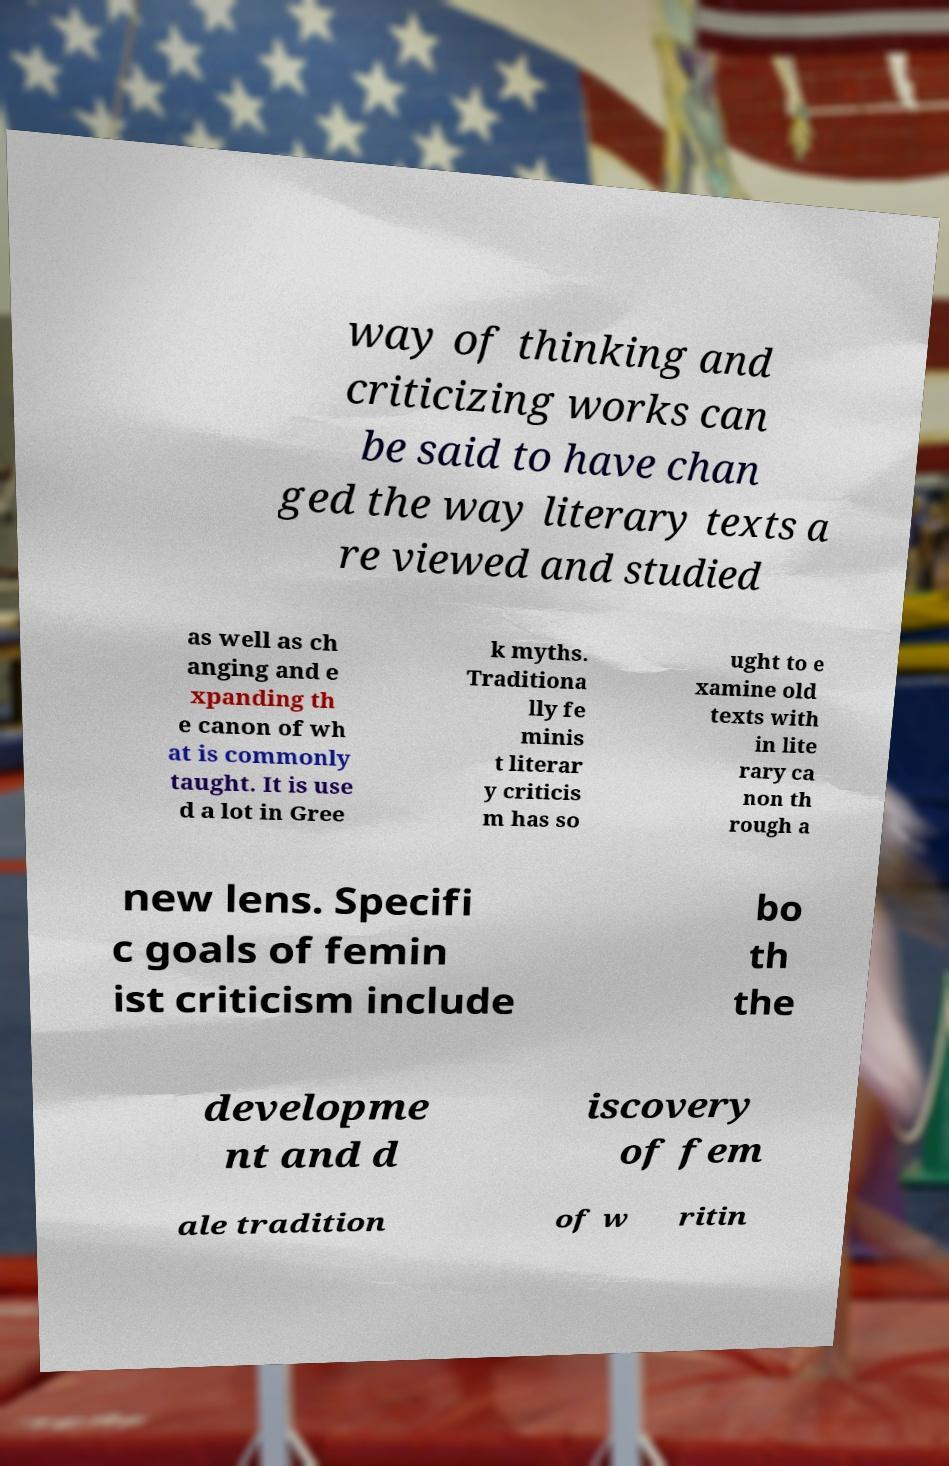Please read and relay the text visible in this image. What does it say? way of thinking and criticizing works can be said to have chan ged the way literary texts a re viewed and studied as well as ch anging and e xpanding th e canon of wh at is commonly taught. It is use d a lot in Gree k myths. Traditiona lly fe minis t literar y criticis m has so ught to e xamine old texts with in lite rary ca non th rough a new lens. Specifi c goals of femin ist criticism include bo th the developme nt and d iscovery of fem ale tradition of w ritin 